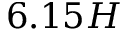Convert formula to latex. <formula><loc_0><loc_0><loc_500><loc_500>6 . 1 5 H</formula> 